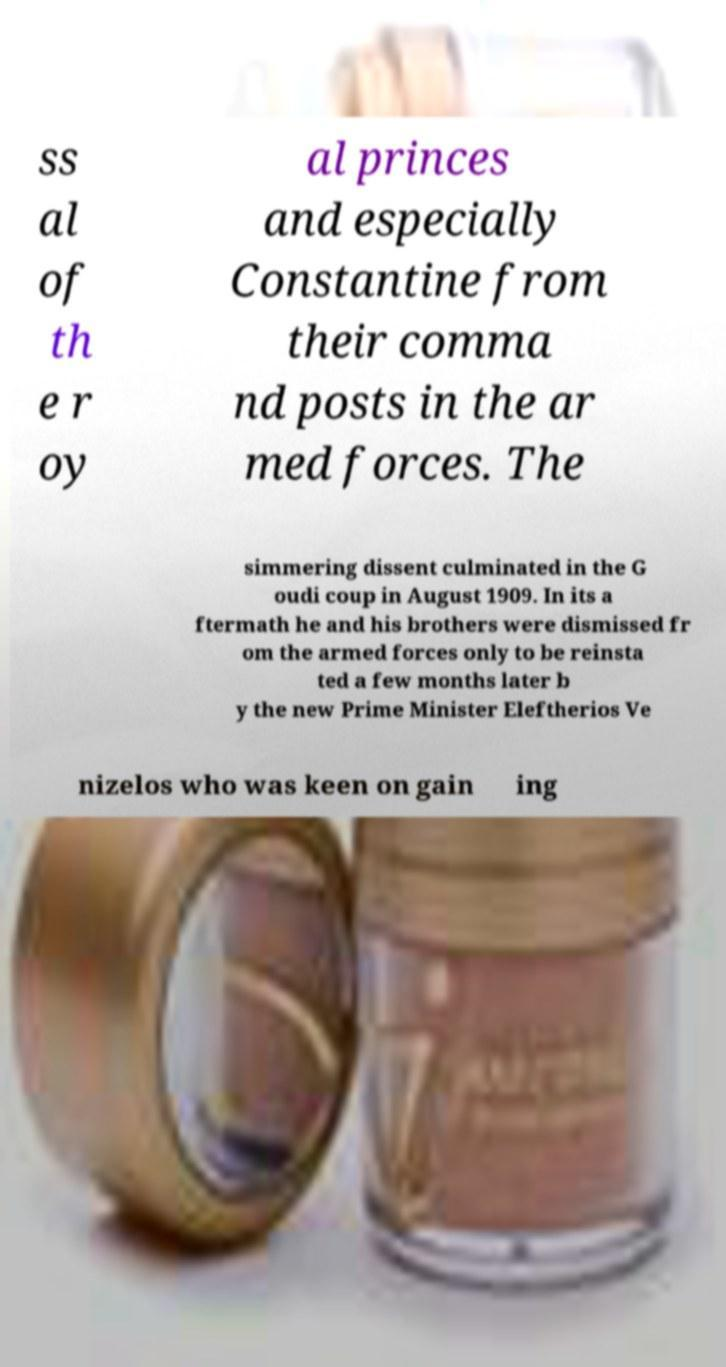Can you accurately transcribe the text from the provided image for me? ss al of th e r oy al princes and especially Constantine from their comma nd posts in the ar med forces. The simmering dissent culminated in the G oudi coup in August 1909. In its a ftermath he and his brothers were dismissed fr om the armed forces only to be reinsta ted a few months later b y the new Prime Minister Eleftherios Ve nizelos who was keen on gain ing 